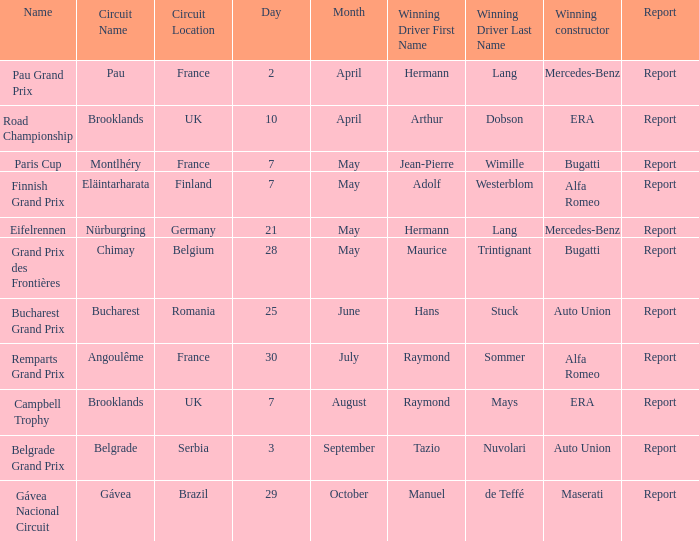Tell me the report for 30 july Report. 